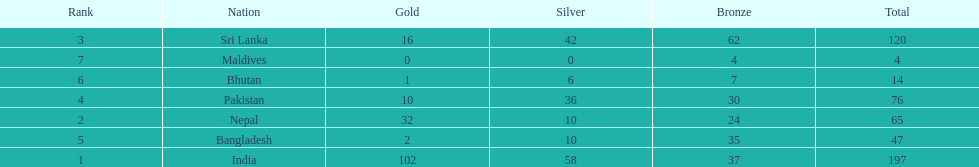What was the number of silver medals won by pakistan? 36. 